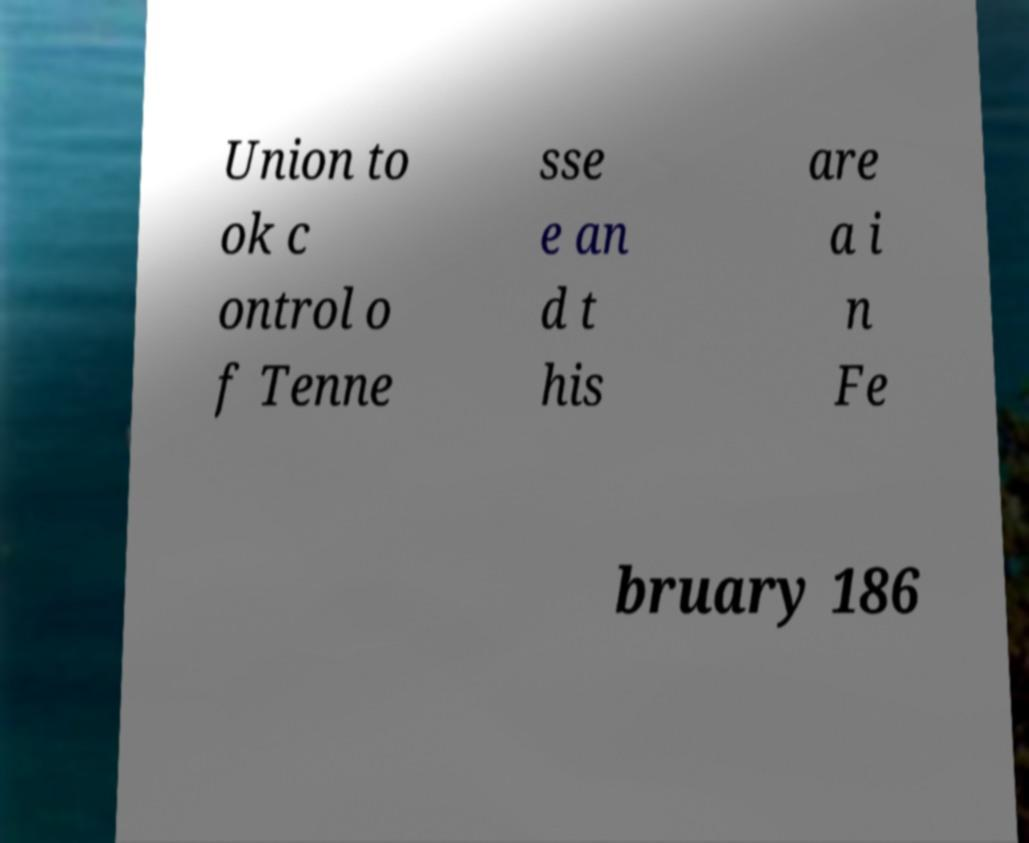I need the written content from this picture converted into text. Can you do that? Union to ok c ontrol o f Tenne sse e an d t his are a i n Fe bruary 186 